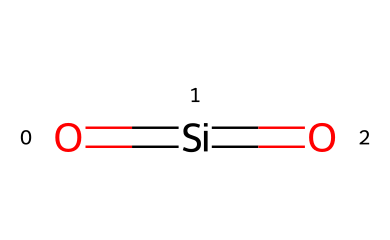What is the central atom in this molecule? The chemical structure provided has silicon (Si) as the central atom, indicated by its position within the molecule and the surrounding double bonds with oxygen.
Answer: silicon How many oxygen atoms are present in the molecule? By analyzing the structure, there are two oxygen atoms that are bonded to the silicon atom, each forming a double bond indicated by the '=' in the SMILES representation.
Answer: two What type of bonding is present between silicon and oxygen in this molecule? The structure indicates double bonds between silicon and each oxygen atom, which signifies a strong covalent bonding type commonly found in silica compounds.
Answer: double bond What property of this silica composition contributes to shear thickening in fluids? The network of strong covalent bonds and the unique particle shape allow for increased interaction under shear stress, leading to increased viscosity; this is a characteristic property of shear-thickening fluids.
Answer: viscosity Why is this compound significant in protective gear? The silica particles provide structural integrity and enhance the protective properties of materials by altering their behavior under stress, making them ideal for impact absorption in protective gear.
Answer: impact absorption How does the molecular structure contribute to its classification as a non-Newtonian fluid? The specific arrangement of silicon and oxygen creates a unique interaction under stress, where the fluid's viscosity changes with the applied shear rate, a hallmark of non-Newtonian behavior.
Answer: viscosity change 